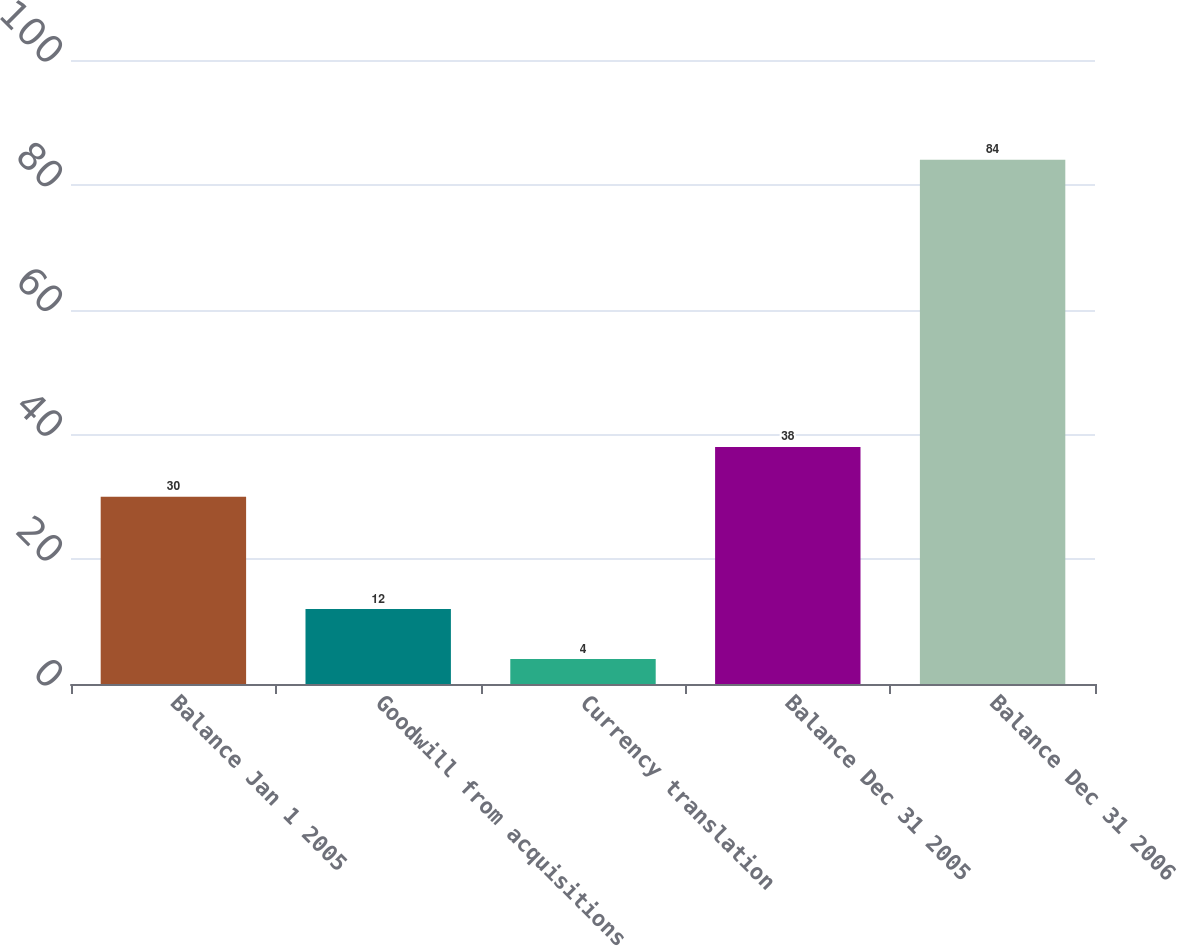Convert chart. <chart><loc_0><loc_0><loc_500><loc_500><bar_chart><fcel>Balance Jan 1 2005<fcel>Goodwill from acquisitions<fcel>Currency translation<fcel>Balance Dec 31 2005<fcel>Balance Dec 31 2006<nl><fcel>30<fcel>12<fcel>4<fcel>38<fcel>84<nl></chart> 